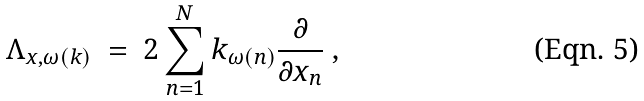<formula> <loc_0><loc_0><loc_500><loc_500>\Lambda _ { x , \omega ( k ) } \ = \ 2 \sum _ { n = 1 } ^ { N } k _ { \omega ( n ) } \frac { \partial } { \partial x _ { n } } \ ,</formula> 